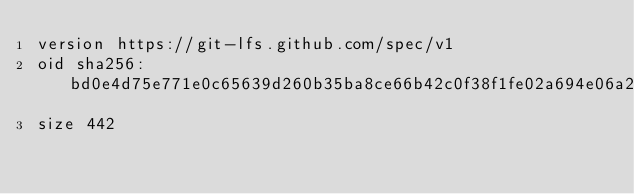<code> <loc_0><loc_0><loc_500><loc_500><_SQL_>version https://git-lfs.github.com/spec/v1
oid sha256:bd0e4d75e771e0c65639d260b35ba8ce66b42c0f38f1fe02a694e06a24bd75e6
size 442
</code> 